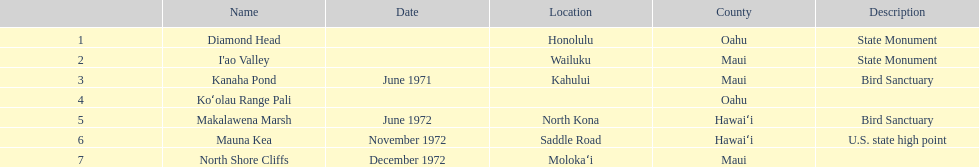Is kanaha pond a state monument or a bird sanctuary? Bird Sanctuary. 